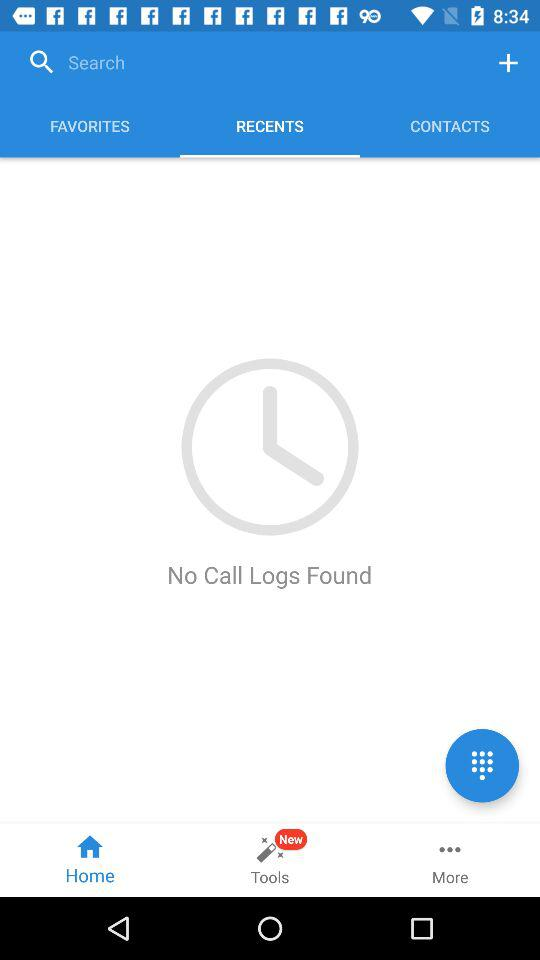Which option has been selected in the bottom row? The selected option is "Home". 